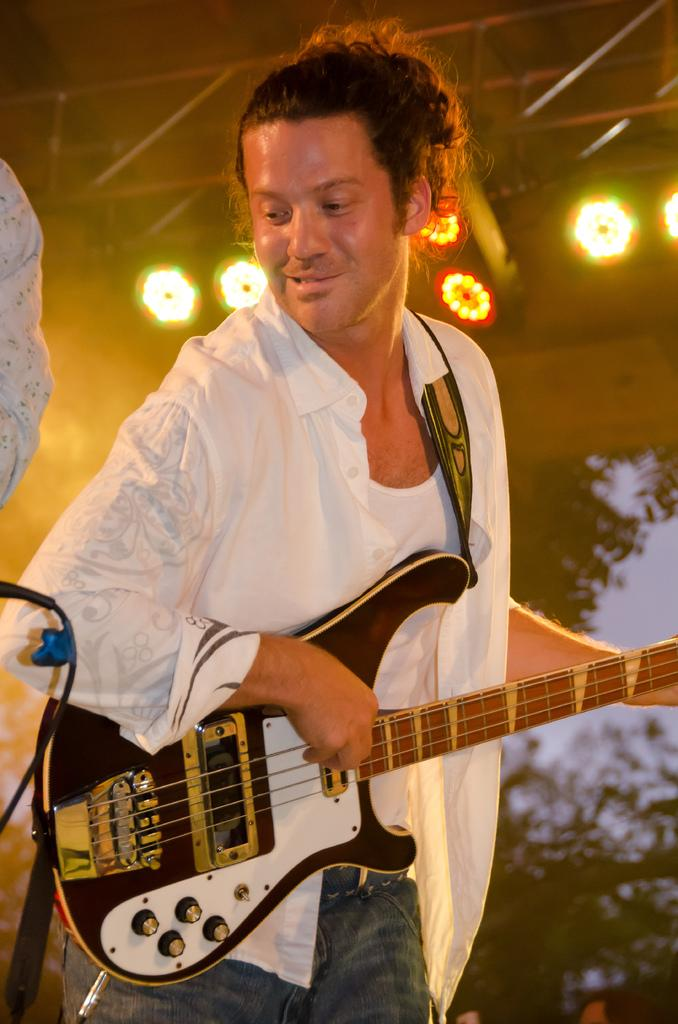What is the man in the image doing? The man is playing a guitar in the image. What is the man wearing? The man is wearing a white shirt and white trousers, and he is also wearing a belt. What can be seen in the background of the image? There is a tree, sky, and a light visible in the image. What type of hook is the man using to play the guitar in the image? There is no hook present in the image; the man is playing the guitar with his hands. What school is the man attending in the image? There is no indication of a school or any educational setting in the image. 